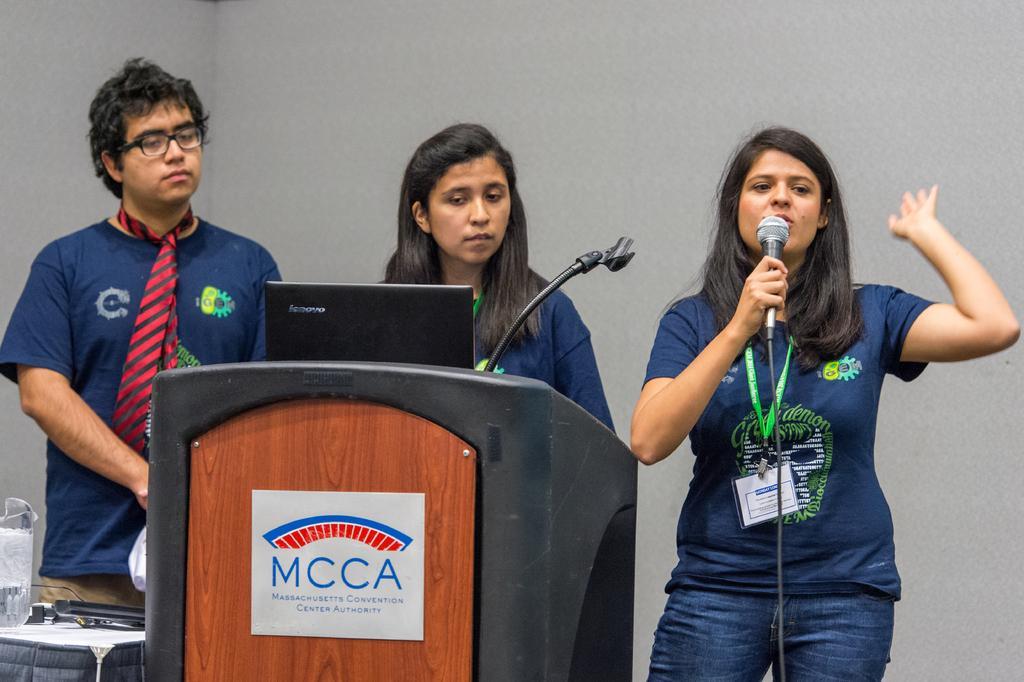In one or two sentences, can you explain what this image depicts? In this image I see a man and 2 women. I can also see that this woman is holding the mic and this woman is in front of the podium. In the background I see the wall. 